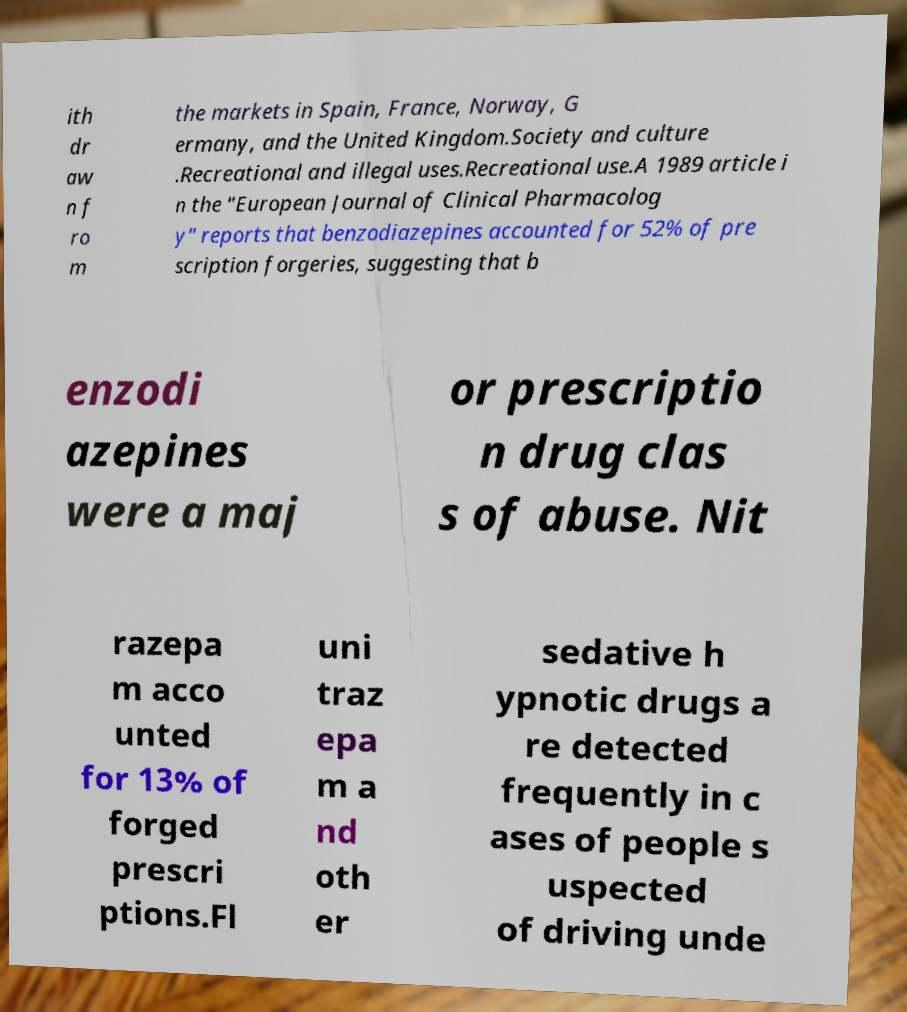Could you extract and type out the text from this image? ith dr aw n f ro m the markets in Spain, France, Norway, G ermany, and the United Kingdom.Society and culture .Recreational and illegal uses.Recreational use.A 1989 article i n the "European Journal of Clinical Pharmacolog y" reports that benzodiazepines accounted for 52% of pre scription forgeries, suggesting that b enzodi azepines were a maj or prescriptio n drug clas s of abuse. Nit razepa m acco unted for 13% of forged prescri ptions.Fl uni traz epa m a nd oth er sedative h ypnotic drugs a re detected frequently in c ases of people s uspected of driving unde 